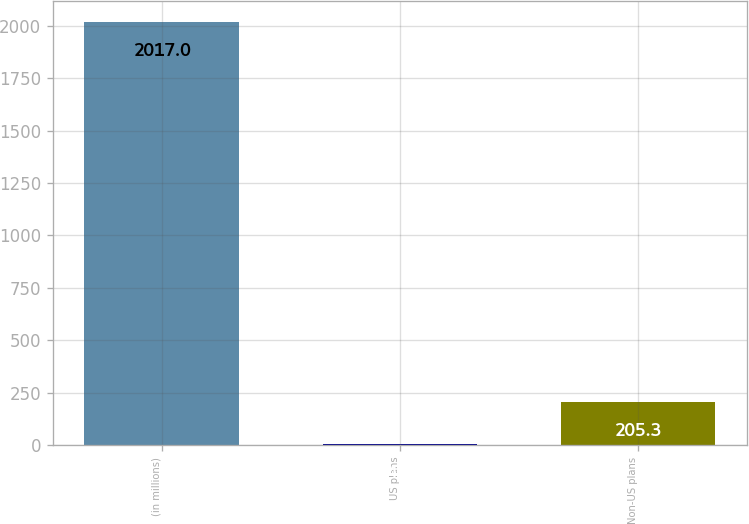<chart> <loc_0><loc_0><loc_500><loc_500><bar_chart><fcel>(in millions)<fcel>US plans<fcel>Non-US plans<nl><fcel>2017<fcel>4<fcel>205.3<nl></chart> 